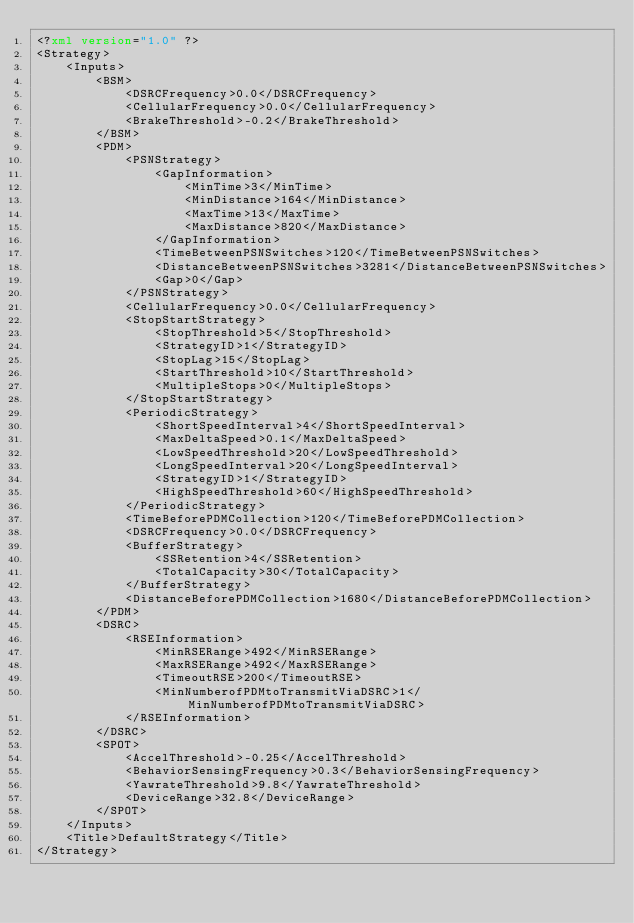Convert code to text. <code><loc_0><loc_0><loc_500><loc_500><_XML_><?xml version="1.0" ?>
<Strategy>
    <Inputs>
        <BSM>
            <DSRCFrequency>0.0</DSRCFrequency>
            <CellularFrequency>0.0</CellularFrequency>
            <BrakeThreshold>-0.2</BrakeThreshold>
        </BSM>
        <PDM>
            <PSNStrategy>
                <GapInformation>
                    <MinTime>3</MinTime>
                    <MinDistance>164</MinDistance>
                    <MaxTime>13</MaxTime>
                    <MaxDistance>820</MaxDistance>
                </GapInformation>
                <TimeBetweenPSNSwitches>120</TimeBetweenPSNSwitches>
                <DistanceBetweenPSNSwitches>3281</DistanceBetweenPSNSwitches>
                <Gap>0</Gap>
            </PSNStrategy>
            <CellularFrequency>0.0</CellularFrequency>
            <StopStartStrategy>
                <StopThreshold>5</StopThreshold>
                <StrategyID>1</StrategyID>
                <StopLag>15</StopLag>
                <StartThreshold>10</StartThreshold>
                <MultipleStops>0</MultipleStops>
            </StopStartStrategy>
            <PeriodicStrategy>
                <ShortSpeedInterval>4</ShortSpeedInterval>
                <MaxDeltaSpeed>0.1</MaxDeltaSpeed>
                <LowSpeedThreshold>20</LowSpeedThreshold>
                <LongSpeedInterval>20</LongSpeedInterval>
                <StrategyID>1</StrategyID>
                <HighSpeedThreshold>60</HighSpeedThreshold>
            </PeriodicStrategy>
            <TimeBeforePDMCollection>120</TimeBeforePDMCollection>
            <DSRCFrequency>0.0</DSRCFrequency>
            <BufferStrategy>
                <SSRetention>4</SSRetention>
                <TotalCapacity>30</TotalCapacity>
            </BufferStrategy>
            <DistanceBeforePDMCollection>1680</DistanceBeforePDMCollection>
        </PDM>
        <DSRC>
            <RSEInformation>
                <MinRSERange>492</MinRSERange>
                <MaxRSERange>492</MaxRSERange>
                <TimeoutRSE>200</TimeoutRSE>
                <MinNumberofPDMtoTransmitViaDSRC>1</MinNumberofPDMtoTransmitViaDSRC>
            </RSEInformation>
        </DSRC>
        <SPOT>
            <AccelThreshold>-0.25</AccelThreshold>
            <BehaviorSensingFrequency>0.3</BehaviorSensingFrequency>
            <YawrateThreshold>9.8</YawrateThreshold>
            <DeviceRange>32.8</DeviceRange>
        </SPOT>
    </Inputs>
    <Title>DefaultStrategy</Title>
</Strategy>
</code> 